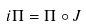<formula> <loc_0><loc_0><loc_500><loc_500>i \Pi = \Pi \circ J</formula> 